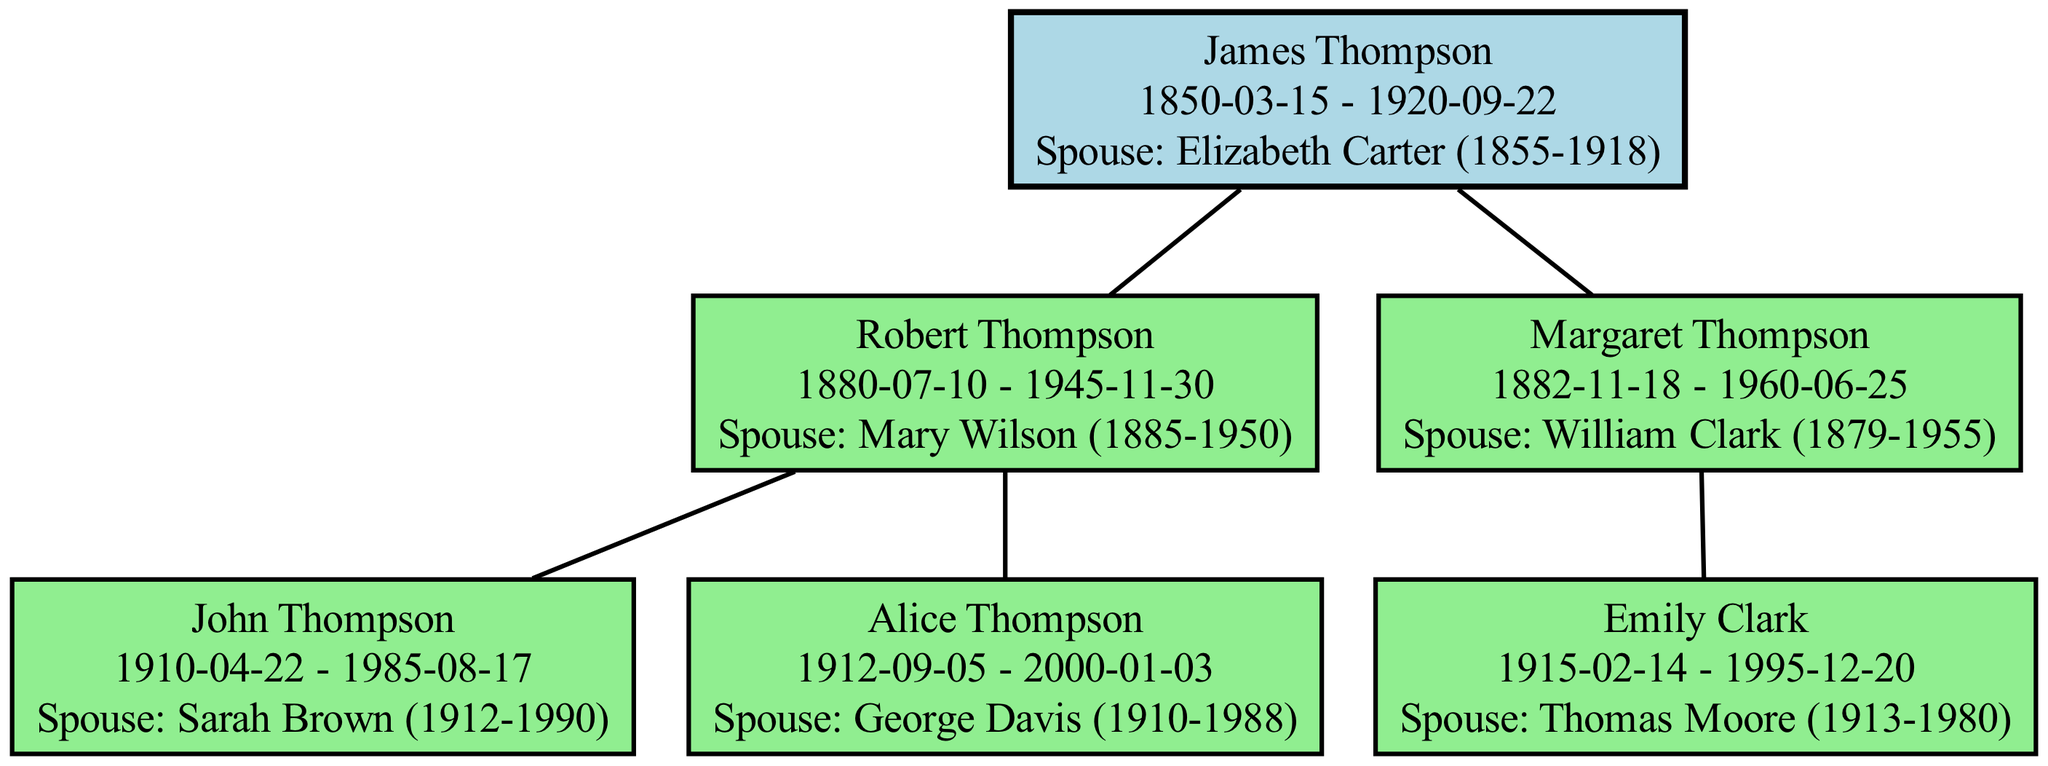What is the birth year of James Thompson? According to the diagram, James Thompson's birth date is given as "1850-03-15". From this date, we can extract the year, which is 1850.
Answer: 1850 How many children does Robert Thompson have? Looking at the diagram, Robert Thompson has two children listed: John Thompson and Alice Thompson. Therefore, the total number of children is 2.
Answer: 2 What is the death year of Elizabeth Carter? The spouse of James Thompson is identified as Elizabeth Carter, whose death date is provided in the diagram as "1918". Thus, the answer is the year she passed away, which is 1918.
Answer: 1918 Who is the spouse of Margaret Thompson? The diagram states that Margaret Thompson's spouse is William Clark. Therefore, the answer to the question is simply taking this information directly from the diagram.
Answer: William Clark How many total generations are represented in the diagram? The diagram shows three generations: the root generation with James and Elizabeth, their generation with Robert and Margaret (the children) and the third generation with John, Alice, and Emily (the grandchildren). Thus, there are a total of three generations.
Answer: 3 What is the birthdate of Alice Thompson? In the diagram, Alice Thompson's birthdate is specifically stated as "1912-09-05". To answer this question, we simply refer to that information.
Answer: 1912-09-05 Which child of Robert Thompson has children? The diagram indicates that both John Thompson and Alice Thompson are children of Robert Thompson; however, only John Thompson has children, specifically mentioned in his segment. Thus, the answer here is focused on this child's role.
Answer: John Thompson Which spouse of a child in the second generation was born in 1915? In the second generation, the child is Emily Clark, who has a spouse named Thomas Moore. According to the diagram, Thomas Moore was born on "1913-1980", while Emily Clark was born in "1915-02-14". Therefore, it is Emily who was born in 1915.
Answer: Emily Clark 